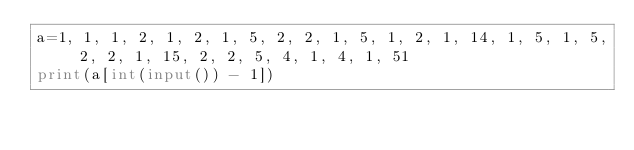<code> <loc_0><loc_0><loc_500><loc_500><_Python_>a=1, 1, 1, 2, 1, 2, 1, 5, 2, 2, 1, 5, 1, 2, 1, 14, 1, 5, 1, 5, 2, 2, 1, 15, 2, 2, 5, 4, 1, 4, 1, 51
print(a[int(input()) - 1])
</code> 